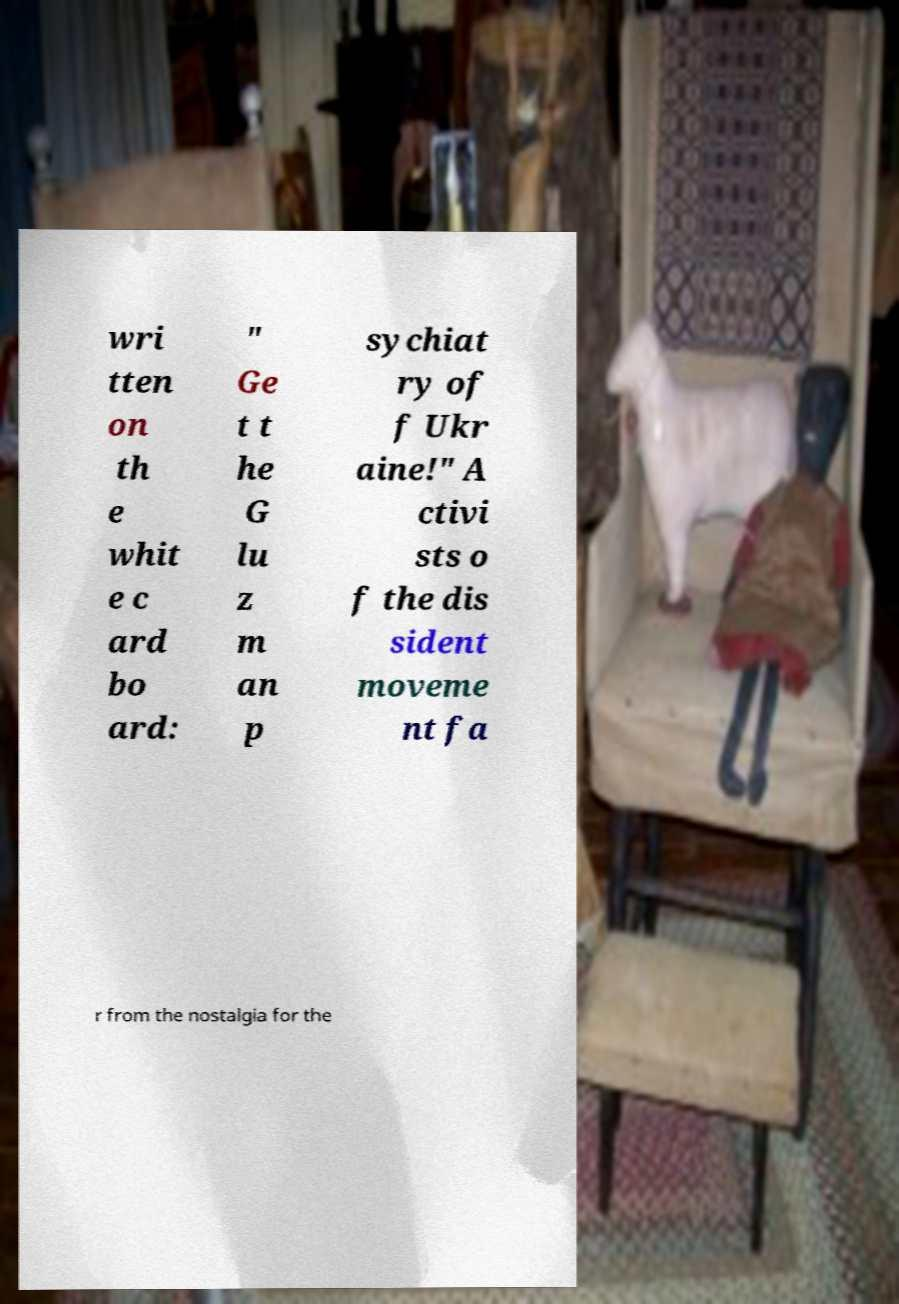Please read and relay the text visible in this image. What does it say? wri tten on th e whit e c ard bo ard: " Ge t t he G lu z m an p sychiat ry of f Ukr aine!" A ctivi sts o f the dis sident moveme nt fa r from the nostalgia for the 